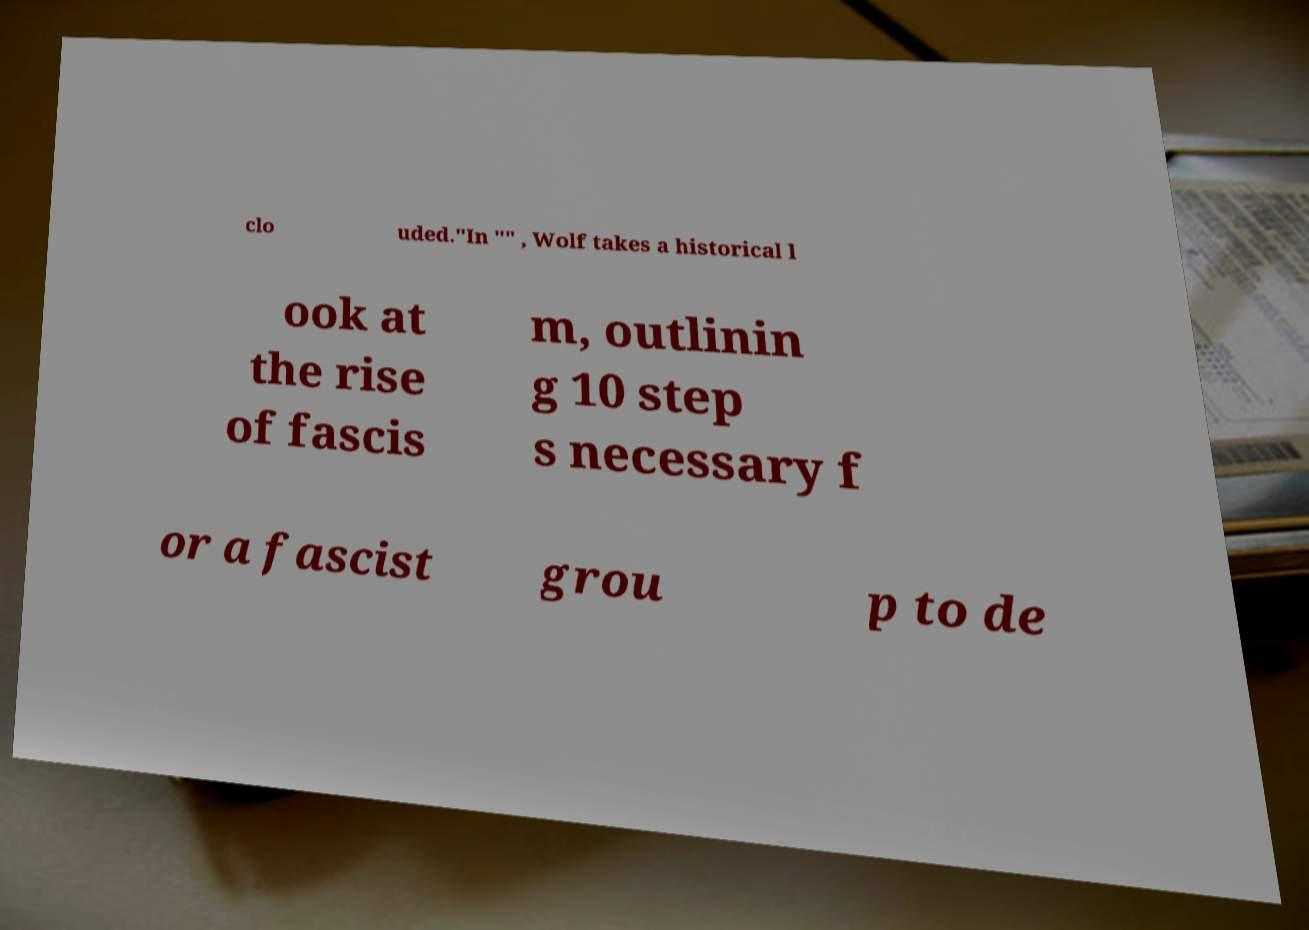I need the written content from this picture converted into text. Can you do that? clo uded."In "" , Wolf takes a historical l ook at the rise of fascis m, outlinin g 10 step s necessary f or a fascist grou p to de 